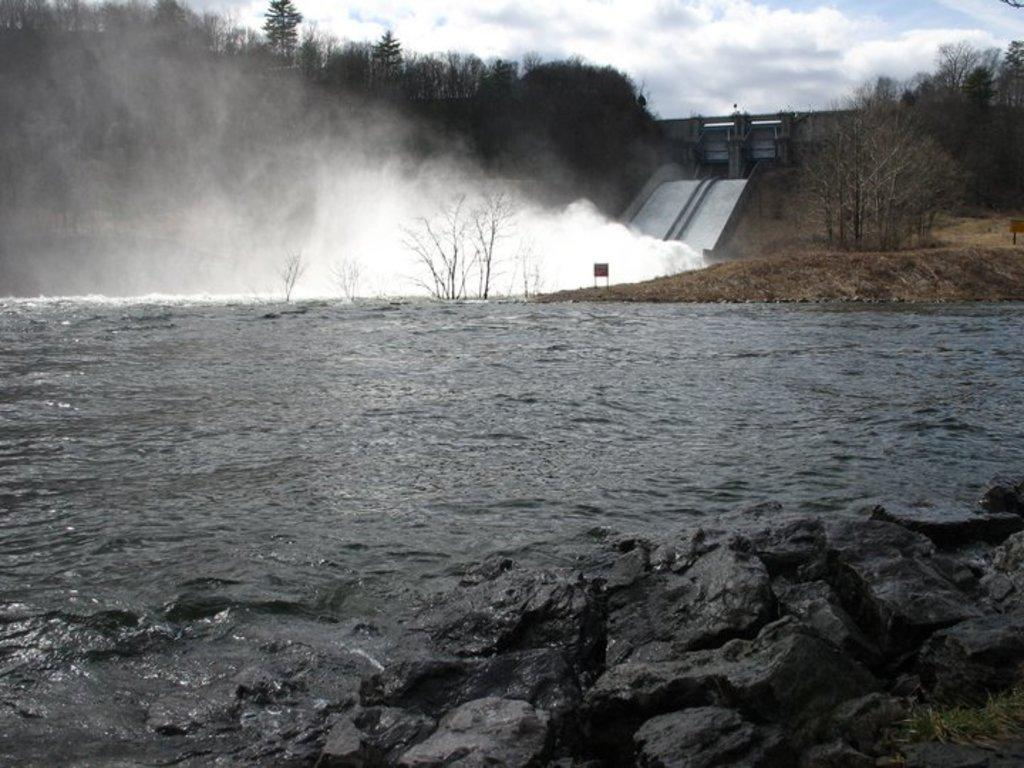What type of natural feature is present in the image? There is a river in the image. What structure can be seen in the background of the image? There is a bridge in the background of the image. What type of vegetation is visible in the background of the image? There are trees in the background of the image. What is visible in the sky in the background of the image? The sky is visible in the background of the image. What color are the eyes of the straw in the image? There is no straw present in the image, and therefore no eyes to describe. What type of food is being served for breakfast in the image? There is no reference to breakfast or any food in the image. 